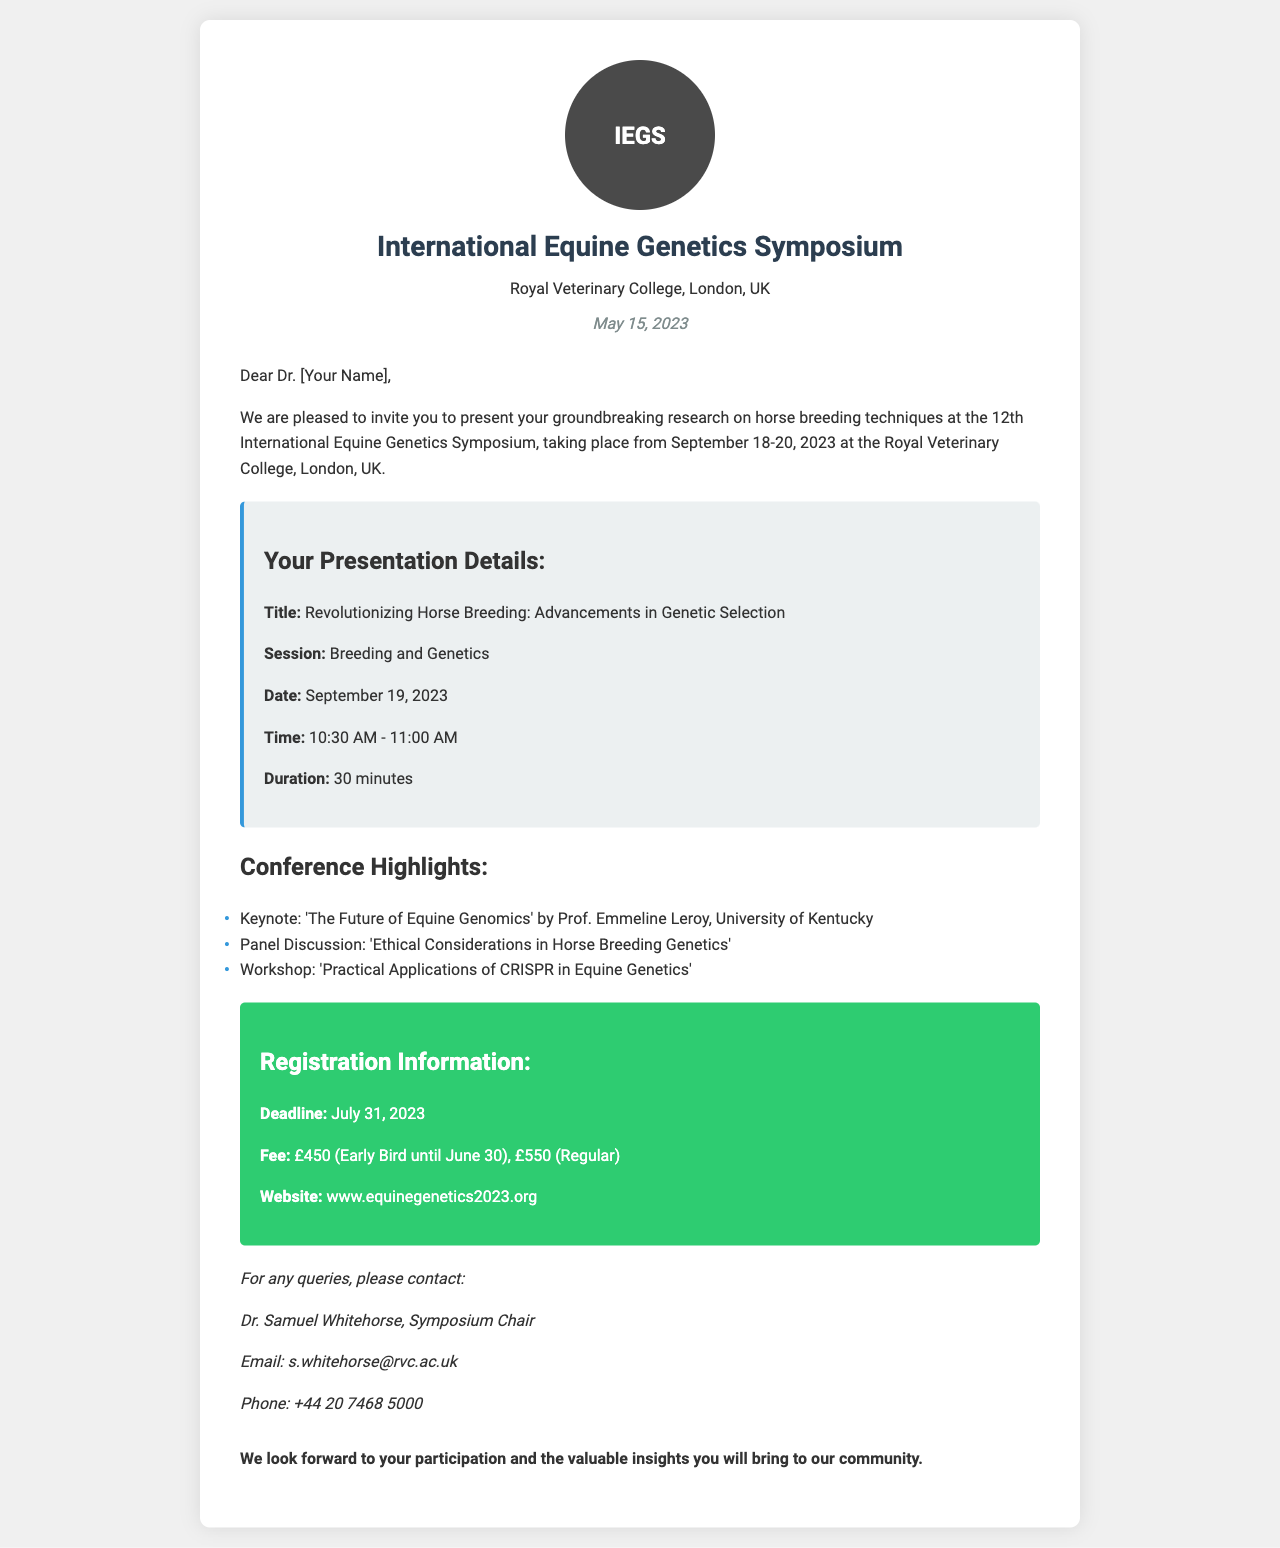What is the date of the symposium? The symposium is scheduled from September 18 to September 20, 2023.
Answer: September 18-20, 2023 Who is the keynote speaker? The keynote speaker is mentioned in the conference highlights as Prof. Emmeline Leroy.
Answer: Prof. Emmeline Leroy What is the title of the presentation? The title of the presentation is stated in the presentation details section.
Answer: Revolutionizing Horse Breeding: Advancements in Genetic Selection What is the registration deadline? The deadline for registration is specified in the registration information section.
Answer: July 31, 2023 What is the early bird registration fee? The early bird registration fee is mentioned alongside the fees for regular registration.
Answer: £450 On which date will the presentation be given? The date for the presentation is provided in the presentation details.
Answer: September 19, 2023 What time is the presentation scheduled? The time for the presentation is clearly indicated in the presentation details.
Answer: 10:30 AM - 11:00 AM Who should be contacted for queries? The contact person for queries is indicated in the contact section.
Answer: Dr. Samuel Whitehorse What is the website for registration? The website for registration is provided in the registration information section.
Answer: www.equinegenetics2023.org 